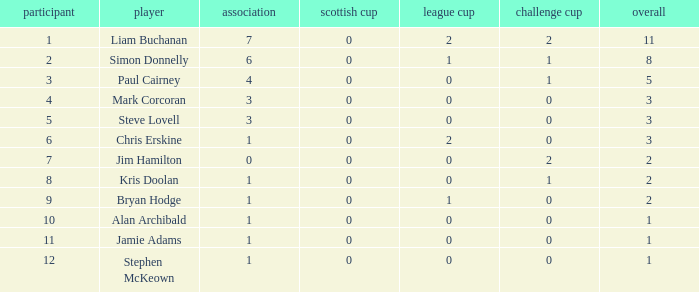What is Kris doolan's league number? 1.0. 